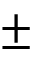<formula> <loc_0><loc_0><loc_500><loc_500>\pm</formula> 